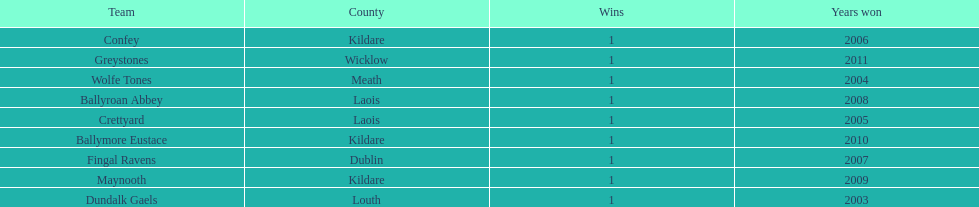Which is the first team from the chart Greystones. 